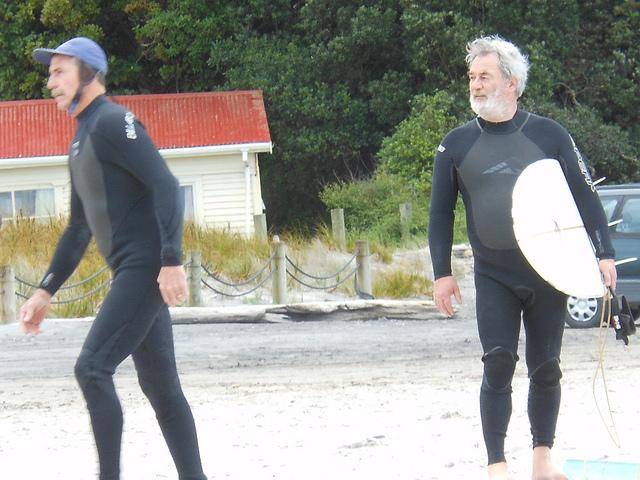Why are there two oval patterns on the right man's pants?

Choices:
A) fashion
B) broken
C) knee protection
D) dress code knee protection 